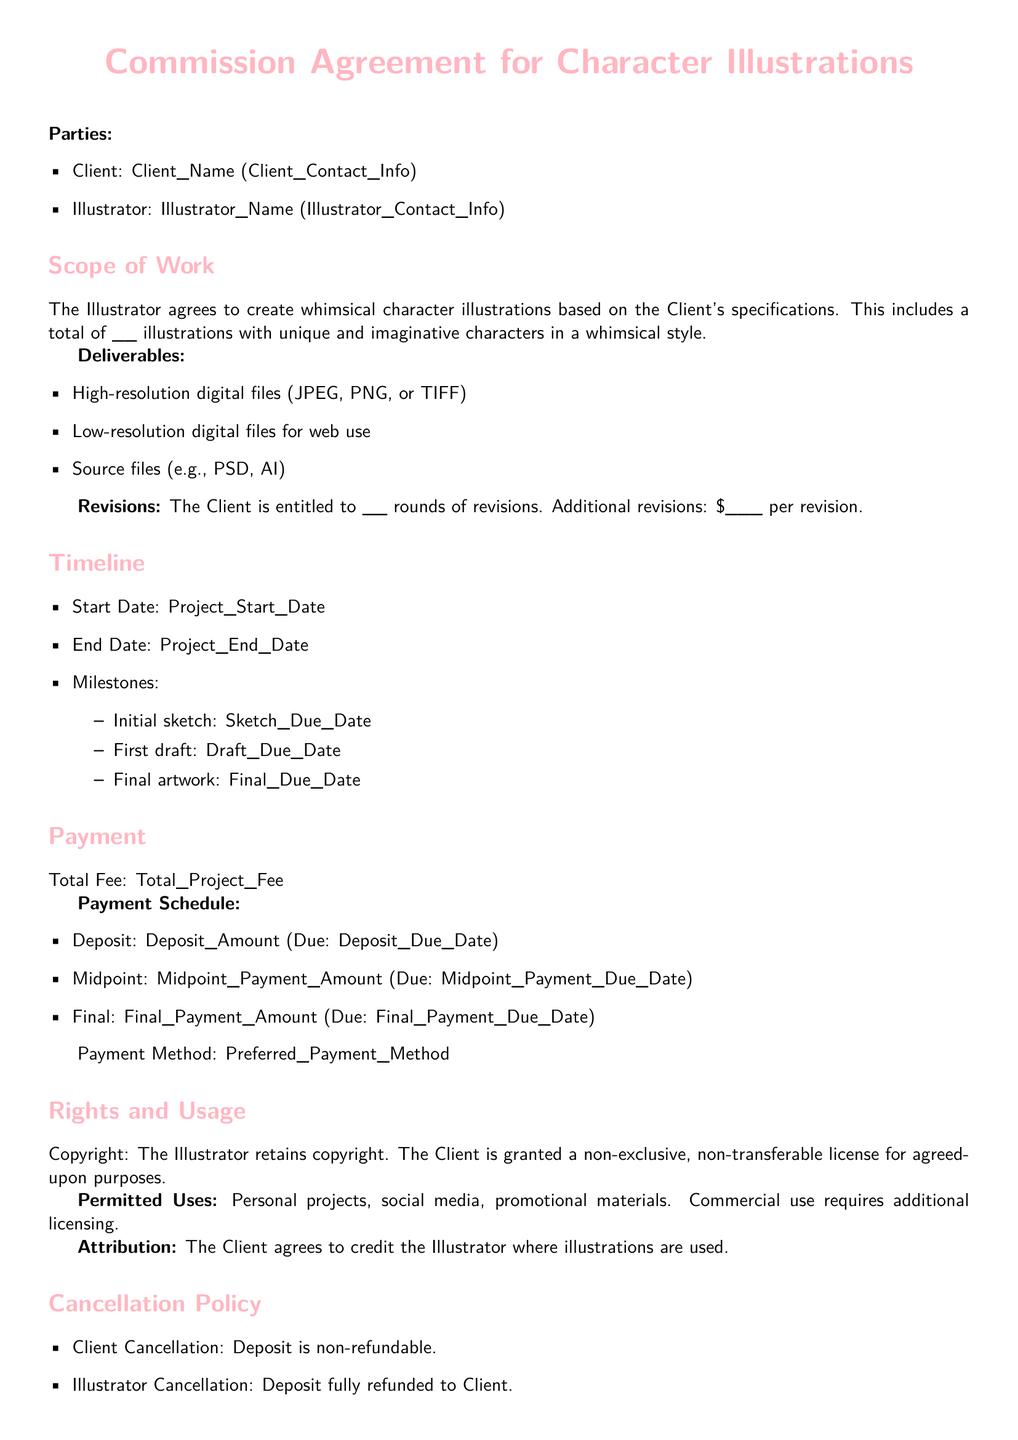What is the Client's Name? The Client's Name is displayed at the beginning of the document in the parties section.
Answer: Client_Name How many rounds of revisions is the Client entitled to? The number of rounds of revisions is specified in the document under the revisions section.
Answer: __ What is the total fee for the project? The total fee is mentioned in the payment section, labeled as Total Fee.
Answer: Total_Project_Fee What is the payment method? The preferred payment method is indicated at the end of the payment section.
Answer: Preferred_Payment_Method What date is the deposit due? The date for the deposit due is stated in the payment schedule of the document.
Answer: Deposit_Due_Date What is the cancellation policy for the Client? The cancellation policy specifics for the Client are written under the cancellation policy section.
Answer: Deposit is non-refundable How many illustrations will be created? The total number of illustrations to be created by the Illustrator is mentioned in the scope of work section.
Answer: __ What files will the Illustrator deliver? The deliverables are listed in the deliverables section of the document.
Answer: High-resolution digital files, Low-resolution digital files, Source files What rights does the Illustrator retain? The copyright ownership is covered under the rights and usage section of the document.
Answer: Copyright What types of uses are permitted for the illustrations? The permitted uses are explicitly stated in the rights and usage section.
Answer: Personal projects, social media, promotional materials 